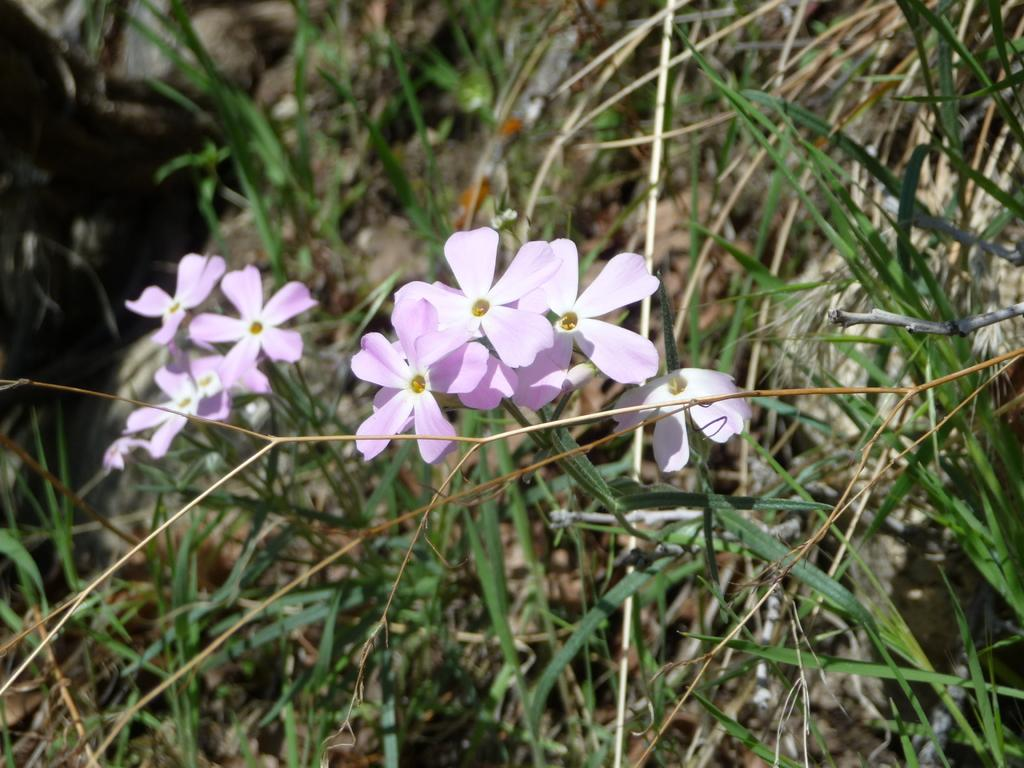What type of living organisms can be seen in the image? Plants can be seen in the image. What color are the plants in the image? The plants are in violet color. What other colors are present in the image? There is yellow color in the image. Are there any green objects in the image? Yes, there are green color objects in the image. How do the plants fight against the flesh in the image? There is no flesh present in the image, and the plants are not fighting against anything. 